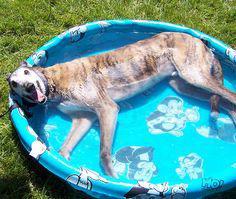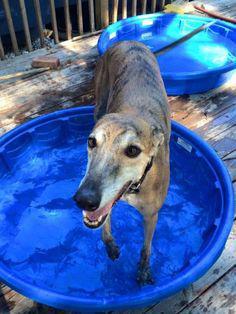The first image is the image on the left, the second image is the image on the right. Evaluate the accuracy of this statement regarding the images: "At least one dog with dark fur is lying down in a small pool.". Is it true? Answer yes or no. No. The first image is the image on the left, the second image is the image on the right. Assess this claim about the two images: "there is a dog laying in a baby pool in the right image". Correct or not? Answer yes or no. No. 